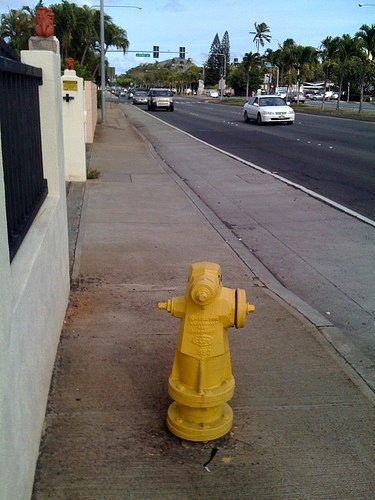Describe the objects in this image and their specific colors. I can see fire hydrant in lightblue, olive, and tan tones, car in lightblue, white, gray, black, and darkgray tones, car in lightblue, black, darkgray, and gray tones, car in lightblue, gray, darkgray, black, and blue tones, and car in lightblue, black, gray, darkgray, and lightgray tones in this image. 